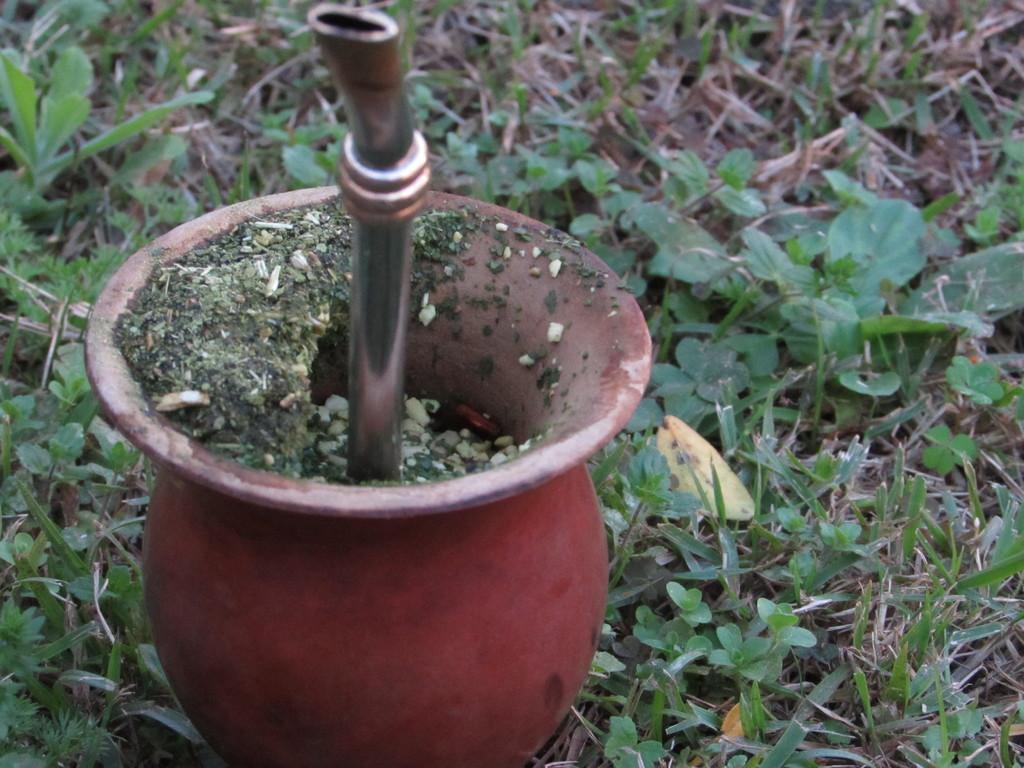What type of object can be found in the flower pot? There is a metallic object in the flower pot. What else is present in the flower pot besides the metallic object? There are small plants in the flower pot. What type of train can be seen in the background of the image? There is no train present in the image; it only features a metallic object and small plants in a flower pot. What facial expression does the flower pot have? The flower pot does not have a face or any facial expression, as it is an inanimate object. 